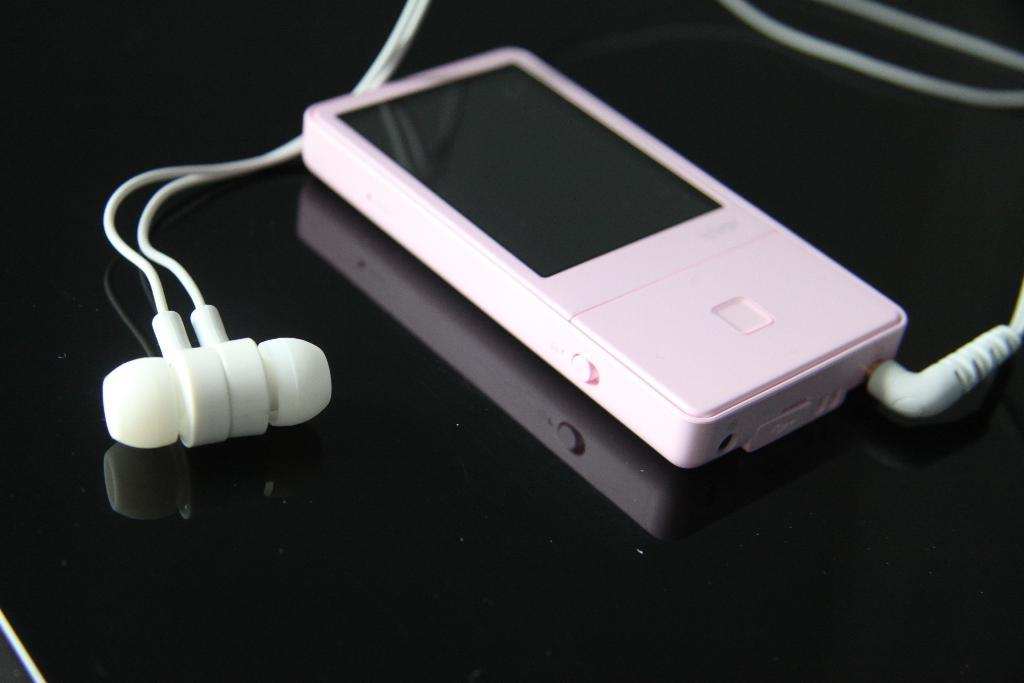What is: What color is the iPod in the image? The iPod in the image is pink. What color are the earphones in the image? The earphones in the image are white. What color is the surface on which the iPod and earphones are placed? The surface is black. How many snails can be seen crawling on the iPod in the image? There are no snails present in the image; it only features a pink iPod and white earphones placed on a black surface. 